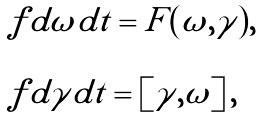Convert formula to latex. <formula><loc_0><loc_0><loc_500><loc_500>\begin{array} { l l l } \ f { d \omega } { d t } = F ( \omega , \gamma ) , \\ \\ \ f { d \gamma } { d t } = [ \gamma , \omega ] \, , \end{array}</formula> 